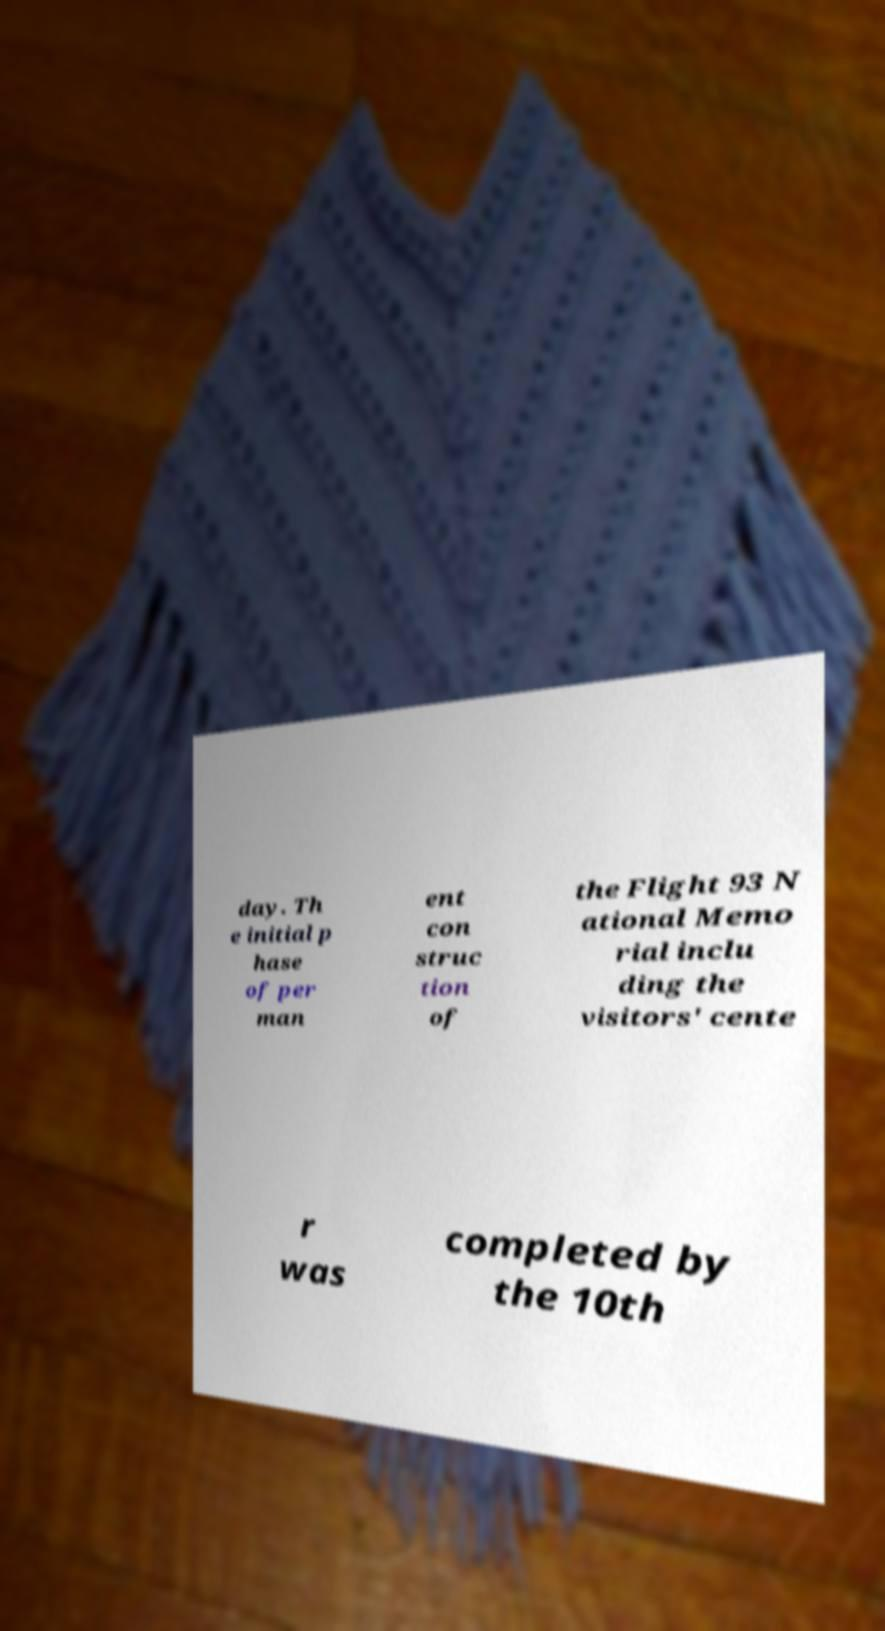Can you read and provide the text displayed in the image?This photo seems to have some interesting text. Can you extract and type it out for me? day. Th e initial p hase of per man ent con struc tion of the Flight 93 N ational Memo rial inclu ding the visitors' cente r was completed by the 10th 